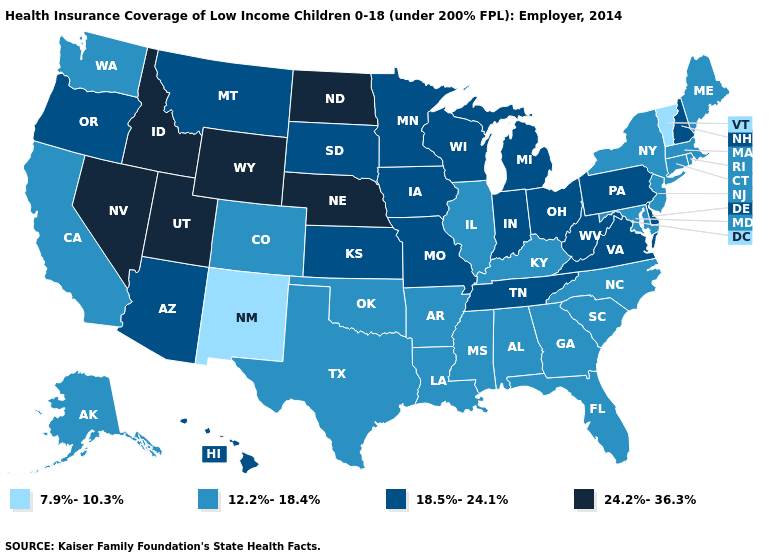How many symbols are there in the legend?
Short answer required. 4. Does Virginia have the highest value in the USA?
Be succinct. No. Which states have the highest value in the USA?
Answer briefly. Idaho, Nebraska, Nevada, North Dakota, Utah, Wyoming. Does the first symbol in the legend represent the smallest category?
Give a very brief answer. Yes. How many symbols are there in the legend?
Quick response, please. 4. How many symbols are there in the legend?
Short answer required. 4. What is the highest value in the Northeast ?
Answer briefly. 18.5%-24.1%. How many symbols are there in the legend?
Concise answer only. 4. Name the states that have a value in the range 12.2%-18.4%?
Keep it brief. Alabama, Alaska, Arkansas, California, Colorado, Connecticut, Florida, Georgia, Illinois, Kentucky, Louisiana, Maine, Maryland, Massachusetts, Mississippi, New Jersey, New York, North Carolina, Oklahoma, Rhode Island, South Carolina, Texas, Washington. Name the states that have a value in the range 18.5%-24.1%?
Short answer required. Arizona, Delaware, Hawaii, Indiana, Iowa, Kansas, Michigan, Minnesota, Missouri, Montana, New Hampshire, Ohio, Oregon, Pennsylvania, South Dakota, Tennessee, Virginia, West Virginia, Wisconsin. What is the highest value in the USA?
Concise answer only. 24.2%-36.3%. Among the states that border Pennsylvania , which have the lowest value?
Be succinct. Maryland, New Jersey, New York. What is the highest value in states that border Virginia?
Give a very brief answer. 18.5%-24.1%. What is the highest value in the USA?
Short answer required. 24.2%-36.3%. What is the value of New Jersey?
Short answer required. 12.2%-18.4%. 